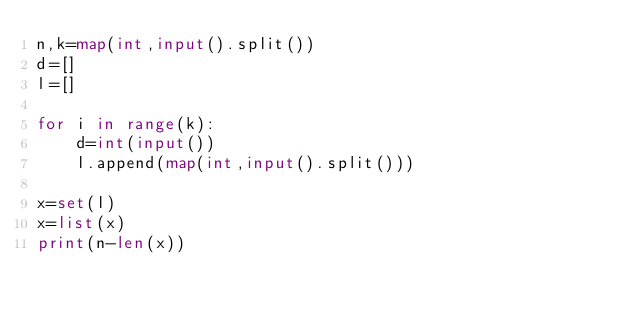Convert code to text. <code><loc_0><loc_0><loc_500><loc_500><_Python_>n,k=map(int,input().split())
d=[]
l=[]

for i in range(k):
    d=int(input())
    l.append(map(int,input().split()))
    
x=set(l)
x=list(x)
print(n-len(x))</code> 